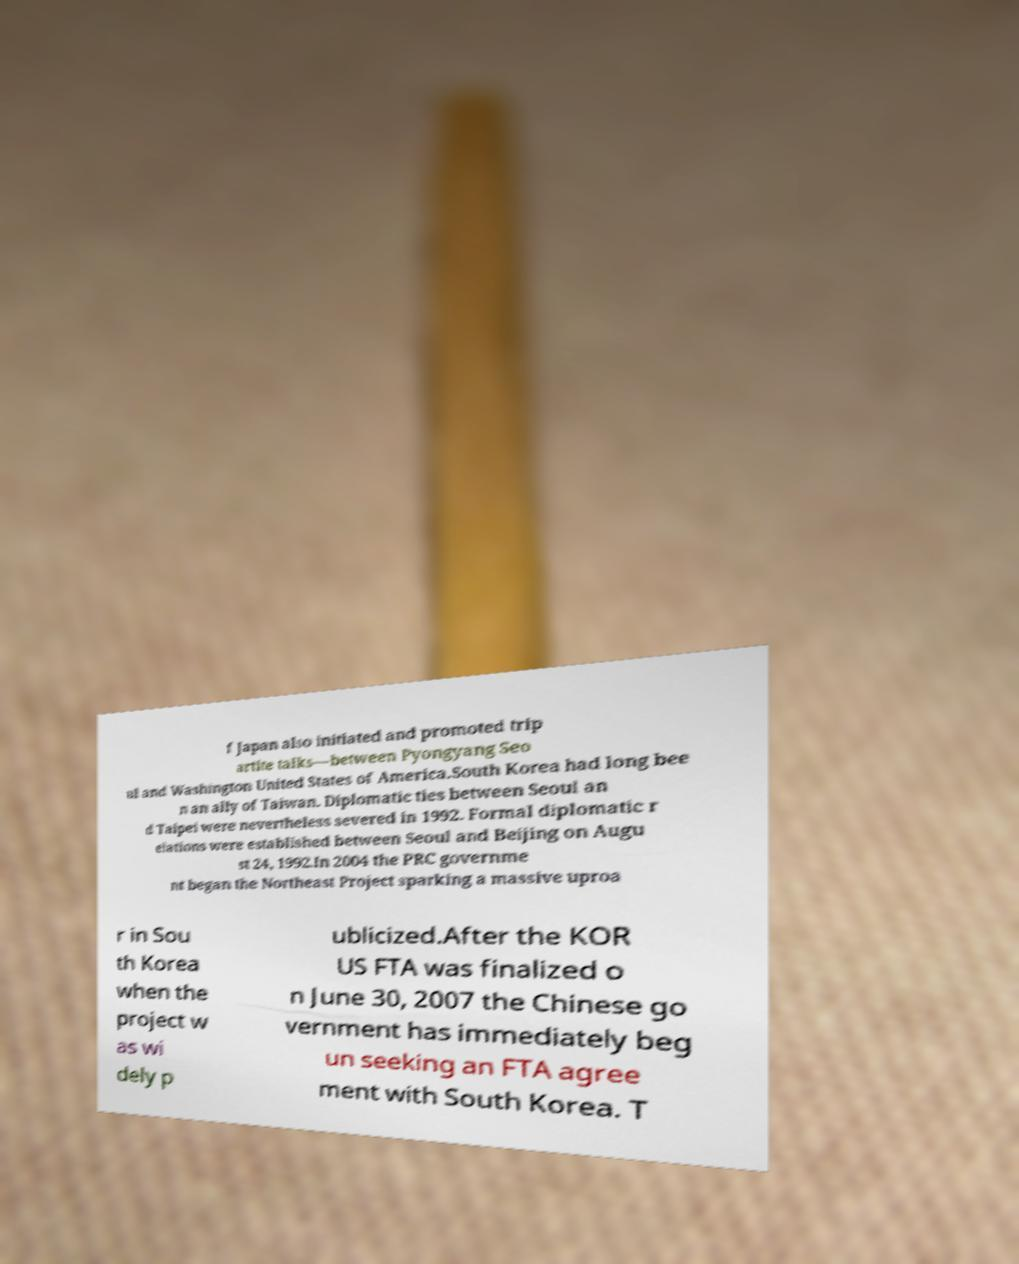Please read and relay the text visible in this image. What does it say? f Japan also initiated and promoted trip artite talks—between Pyongyang Seo ul and Washington United States of America.South Korea had long bee n an ally of Taiwan. Diplomatic ties between Seoul an d Taipei were nevertheless severed in 1992. Formal diplomatic r elations were established between Seoul and Beijing on Augu st 24, 1992.In 2004 the PRC governme nt began the Northeast Project sparking a massive uproa r in Sou th Korea when the project w as wi dely p ublicized.After the KOR US FTA was finalized o n June 30, 2007 the Chinese go vernment has immediately beg un seeking an FTA agree ment with South Korea. T 